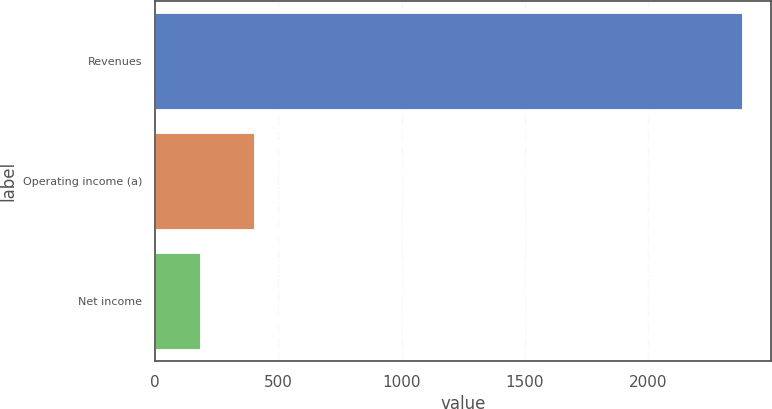Convert chart to OTSL. <chart><loc_0><loc_0><loc_500><loc_500><bar_chart><fcel>Revenues<fcel>Operating income (a)<fcel>Net income<nl><fcel>2379<fcel>399.9<fcel>180<nl></chart> 